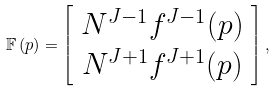<formula> <loc_0><loc_0><loc_500><loc_500>\mathbb { F } \left ( p \right ) = \left [ \begin{array} { c } N ^ { J - 1 } f ^ { J - 1 } ( p ) \\ N ^ { J + 1 } f ^ { J + 1 } ( p ) \end{array} \right ] ,</formula> 